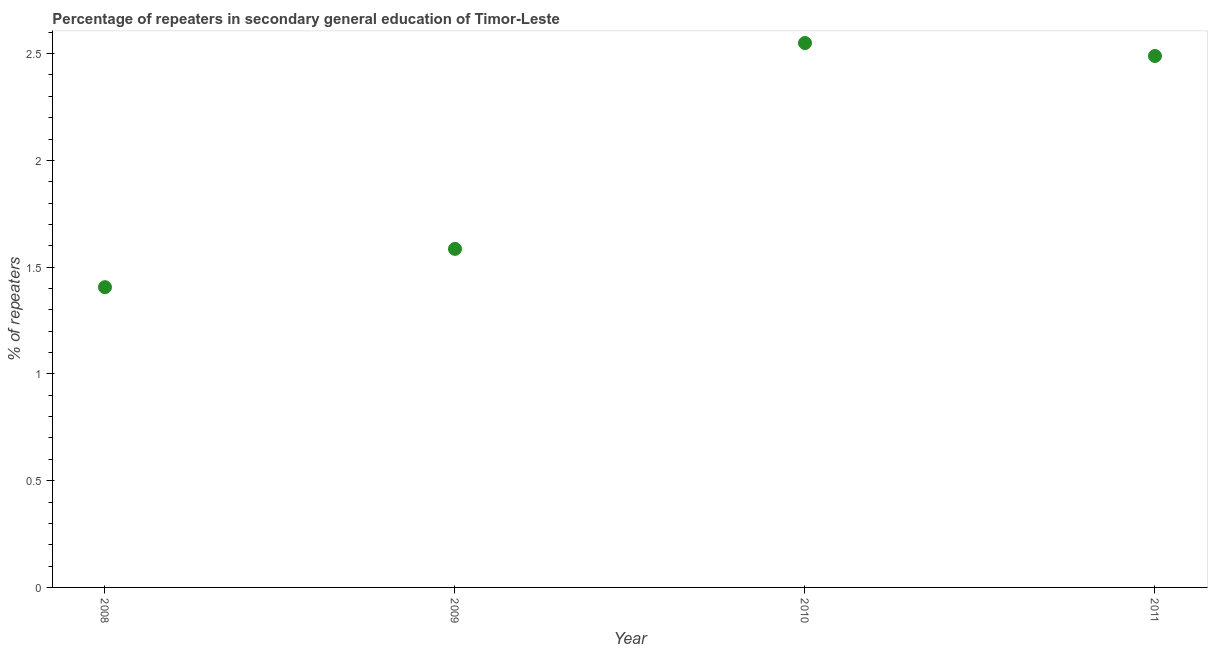What is the percentage of repeaters in 2008?
Your answer should be very brief. 1.41. Across all years, what is the maximum percentage of repeaters?
Keep it short and to the point. 2.55. Across all years, what is the minimum percentage of repeaters?
Make the answer very short. 1.41. In which year was the percentage of repeaters maximum?
Provide a succinct answer. 2010. In which year was the percentage of repeaters minimum?
Provide a short and direct response. 2008. What is the sum of the percentage of repeaters?
Make the answer very short. 8.03. What is the difference between the percentage of repeaters in 2009 and 2010?
Offer a terse response. -0.96. What is the average percentage of repeaters per year?
Give a very brief answer. 2.01. What is the median percentage of repeaters?
Give a very brief answer. 2.04. In how many years, is the percentage of repeaters greater than 2.4 %?
Provide a succinct answer. 2. Do a majority of the years between 2010 and 2008 (inclusive) have percentage of repeaters greater than 1.9 %?
Your response must be concise. No. What is the ratio of the percentage of repeaters in 2009 to that in 2010?
Give a very brief answer. 0.62. Is the percentage of repeaters in 2008 less than that in 2009?
Ensure brevity in your answer.  Yes. What is the difference between the highest and the second highest percentage of repeaters?
Provide a succinct answer. 0.06. What is the difference between the highest and the lowest percentage of repeaters?
Offer a terse response. 1.14. In how many years, is the percentage of repeaters greater than the average percentage of repeaters taken over all years?
Provide a short and direct response. 2. Does the percentage of repeaters monotonically increase over the years?
Ensure brevity in your answer.  No. How many years are there in the graph?
Offer a terse response. 4. What is the difference between two consecutive major ticks on the Y-axis?
Your answer should be compact. 0.5. Are the values on the major ticks of Y-axis written in scientific E-notation?
Your answer should be compact. No. Does the graph contain any zero values?
Keep it short and to the point. No. What is the title of the graph?
Ensure brevity in your answer.  Percentage of repeaters in secondary general education of Timor-Leste. What is the label or title of the X-axis?
Your answer should be compact. Year. What is the label or title of the Y-axis?
Ensure brevity in your answer.  % of repeaters. What is the % of repeaters in 2008?
Your response must be concise. 1.41. What is the % of repeaters in 2009?
Keep it short and to the point. 1.59. What is the % of repeaters in 2010?
Your answer should be very brief. 2.55. What is the % of repeaters in 2011?
Your response must be concise. 2.49. What is the difference between the % of repeaters in 2008 and 2009?
Offer a very short reply. -0.18. What is the difference between the % of repeaters in 2008 and 2010?
Your answer should be compact. -1.14. What is the difference between the % of repeaters in 2008 and 2011?
Ensure brevity in your answer.  -1.08. What is the difference between the % of repeaters in 2009 and 2010?
Your response must be concise. -0.96. What is the difference between the % of repeaters in 2009 and 2011?
Provide a succinct answer. -0.9. What is the difference between the % of repeaters in 2010 and 2011?
Make the answer very short. 0.06. What is the ratio of the % of repeaters in 2008 to that in 2009?
Provide a short and direct response. 0.89. What is the ratio of the % of repeaters in 2008 to that in 2010?
Provide a succinct answer. 0.55. What is the ratio of the % of repeaters in 2008 to that in 2011?
Your answer should be very brief. 0.56. What is the ratio of the % of repeaters in 2009 to that in 2010?
Make the answer very short. 0.62. What is the ratio of the % of repeaters in 2009 to that in 2011?
Offer a very short reply. 0.64. What is the ratio of the % of repeaters in 2010 to that in 2011?
Ensure brevity in your answer.  1.02. 